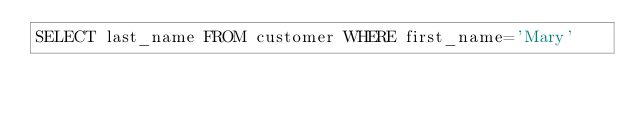Convert code to text. <code><loc_0><loc_0><loc_500><loc_500><_SQL_>SELECT last_name FROM customer WHERE first_name='Mary'</code> 